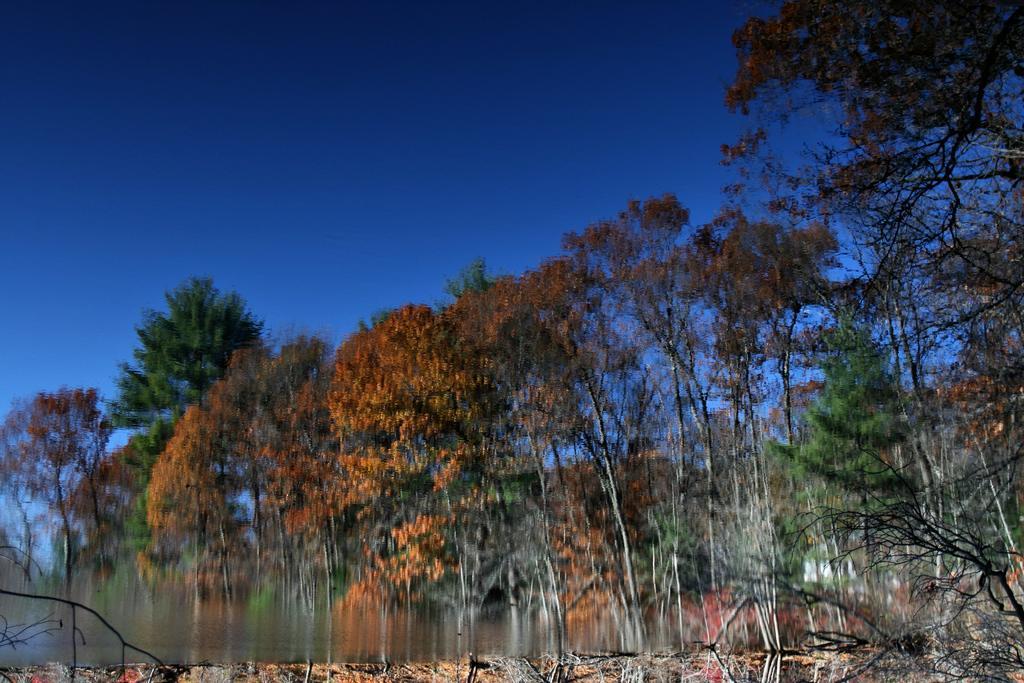Describe this image in one or two sentences. This is an edited image. In this picture, there are trees. At the top, we see the sky, which is blue in color. This picture is blurred at the bottom. 